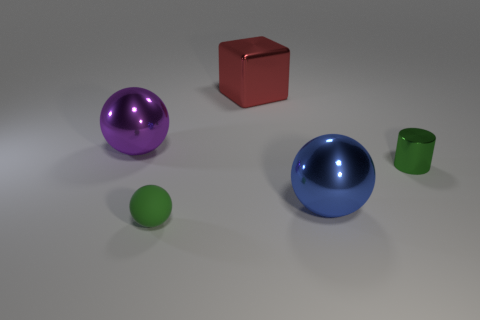Is there any other thing that has the same size as the metal cube?
Provide a short and direct response. Yes. What color is the cube that is the same material as the small cylinder?
Offer a very short reply. Red. Is the number of metallic cubes on the left side of the purple shiny object less than the number of metal cylinders in front of the tiny sphere?
Ensure brevity in your answer.  No. What number of other tiny metal things are the same color as the small shiny thing?
Ensure brevity in your answer.  0. There is another tiny object that is the same color as the small matte thing; what is it made of?
Provide a succinct answer. Metal. How many shiny objects are both left of the metal cylinder and to the right of the red thing?
Offer a very short reply. 1. What material is the large ball that is in front of the sphere that is behind the small green cylinder?
Offer a very short reply. Metal. Are there any small green things made of the same material as the big cube?
Your answer should be very brief. Yes. What material is the purple sphere that is the same size as the shiny cube?
Your answer should be very brief. Metal. How big is the metal sphere that is in front of the metal ball behind the large blue sphere in front of the large red cube?
Your response must be concise. Large. 